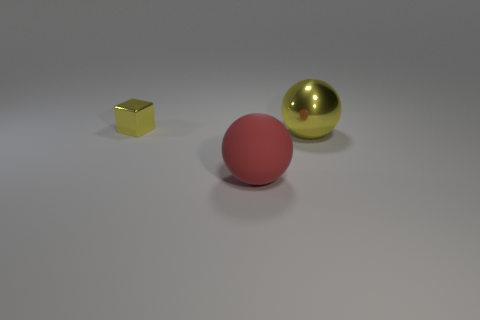Add 1 big things. How many objects exist? 4 Subtract all cubes. How many objects are left? 2 Subtract 1 yellow blocks. How many objects are left? 2 Subtract all small red metal spheres. Subtract all big red objects. How many objects are left? 2 Add 3 yellow metallic cubes. How many yellow metallic cubes are left? 4 Add 1 large brown metal objects. How many large brown metal objects exist? 1 